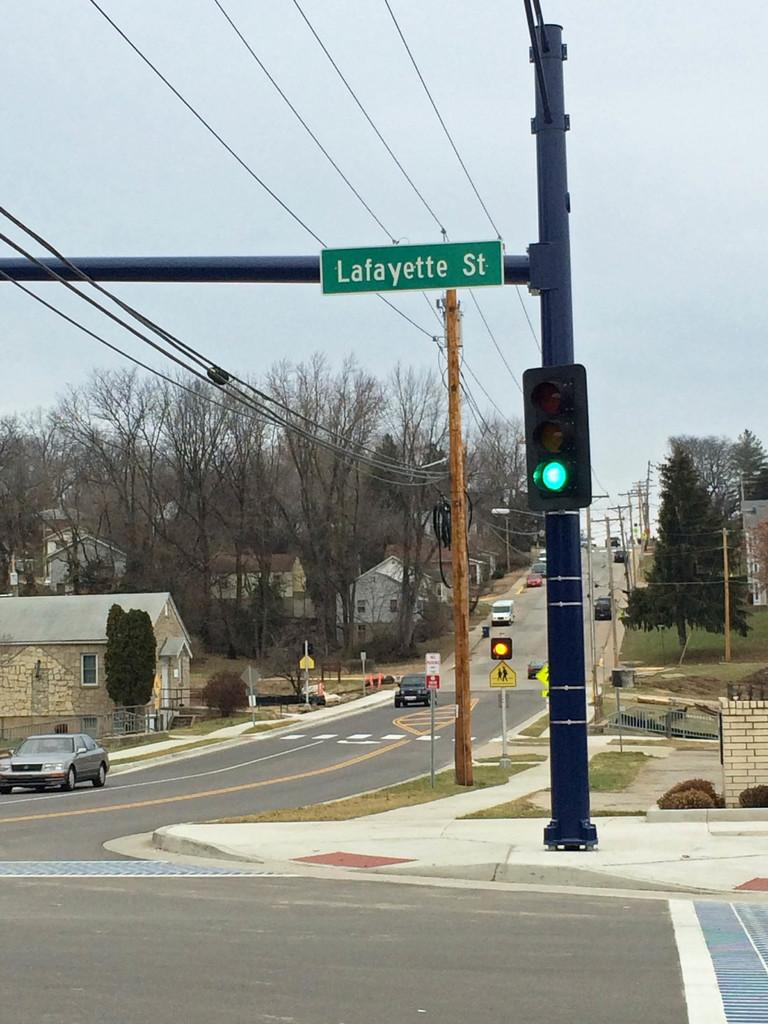<image>
Present a compact description of the photo's key features. A street corner with a green light at Lafayette St. 